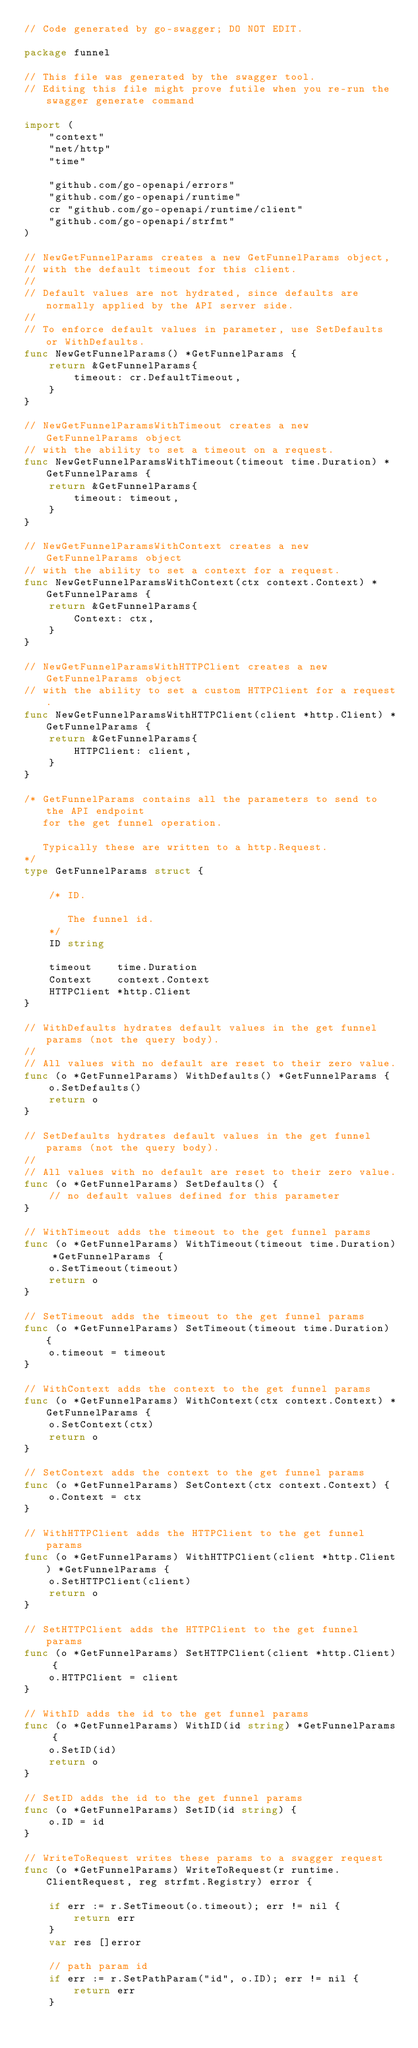Convert code to text. <code><loc_0><loc_0><loc_500><loc_500><_Go_>// Code generated by go-swagger; DO NOT EDIT.

package funnel

// This file was generated by the swagger tool.
// Editing this file might prove futile when you re-run the swagger generate command

import (
	"context"
	"net/http"
	"time"

	"github.com/go-openapi/errors"
	"github.com/go-openapi/runtime"
	cr "github.com/go-openapi/runtime/client"
	"github.com/go-openapi/strfmt"
)

// NewGetFunnelParams creates a new GetFunnelParams object,
// with the default timeout for this client.
//
// Default values are not hydrated, since defaults are normally applied by the API server side.
//
// To enforce default values in parameter, use SetDefaults or WithDefaults.
func NewGetFunnelParams() *GetFunnelParams {
	return &GetFunnelParams{
		timeout: cr.DefaultTimeout,
	}
}

// NewGetFunnelParamsWithTimeout creates a new GetFunnelParams object
// with the ability to set a timeout on a request.
func NewGetFunnelParamsWithTimeout(timeout time.Duration) *GetFunnelParams {
	return &GetFunnelParams{
		timeout: timeout,
	}
}

// NewGetFunnelParamsWithContext creates a new GetFunnelParams object
// with the ability to set a context for a request.
func NewGetFunnelParamsWithContext(ctx context.Context) *GetFunnelParams {
	return &GetFunnelParams{
		Context: ctx,
	}
}

// NewGetFunnelParamsWithHTTPClient creates a new GetFunnelParams object
// with the ability to set a custom HTTPClient for a request.
func NewGetFunnelParamsWithHTTPClient(client *http.Client) *GetFunnelParams {
	return &GetFunnelParams{
		HTTPClient: client,
	}
}

/* GetFunnelParams contains all the parameters to send to the API endpoint
   for the get funnel operation.

   Typically these are written to a http.Request.
*/
type GetFunnelParams struct {

	/* ID.

	   The funnel id.
	*/
	ID string

	timeout    time.Duration
	Context    context.Context
	HTTPClient *http.Client
}

// WithDefaults hydrates default values in the get funnel params (not the query body).
//
// All values with no default are reset to their zero value.
func (o *GetFunnelParams) WithDefaults() *GetFunnelParams {
	o.SetDefaults()
	return o
}

// SetDefaults hydrates default values in the get funnel params (not the query body).
//
// All values with no default are reset to their zero value.
func (o *GetFunnelParams) SetDefaults() {
	// no default values defined for this parameter
}

// WithTimeout adds the timeout to the get funnel params
func (o *GetFunnelParams) WithTimeout(timeout time.Duration) *GetFunnelParams {
	o.SetTimeout(timeout)
	return o
}

// SetTimeout adds the timeout to the get funnel params
func (o *GetFunnelParams) SetTimeout(timeout time.Duration) {
	o.timeout = timeout
}

// WithContext adds the context to the get funnel params
func (o *GetFunnelParams) WithContext(ctx context.Context) *GetFunnelParams {
	o.SetContext(ctx)
	return o
}

// SetContext adds the context to the get funnel params
func (o *GetFunnelParams) SetContext(ctx context.Context) {
	o.Context = ctx
}

// WithHTTPClient adds the HTTPClient to the get funnel params
func (o *GetFunnelParams) WithHTTPClient(client *http.Client) *GetFunnelParams {
	o.SetHTTPClient(client)
	return o
}

// SetHTTPClient adds the HTTPClient to the get funnel params
func (o *GetFunnelParams) SetHTTPClient(client *http.Client) {
	o.HTTPClient = client
}

// WithID adds the id to the get funnel params
func (o *GetFunnelParams) WithID(id string) *GetFunnelParams {
	o.SetID(id)
	return o
}

// SetID adds the id to the get funnel params
func (o *GetFunnelParams) SetID(id string) {
	o.ID = id
}

// WriteToRequest writes these params to a swagger request
func (o *GetFunnelParams) WriteToRequest(r runtime.ClientRequest, reg strfmt.Registry) error {

	if err := r.SetTimeout(o.timeout); err != nil {
		return err
	}
	var res []error

	// path param id
	if err := r.SetPathParam("id", o.ID); err != nil {
		return err
	}
</code> 